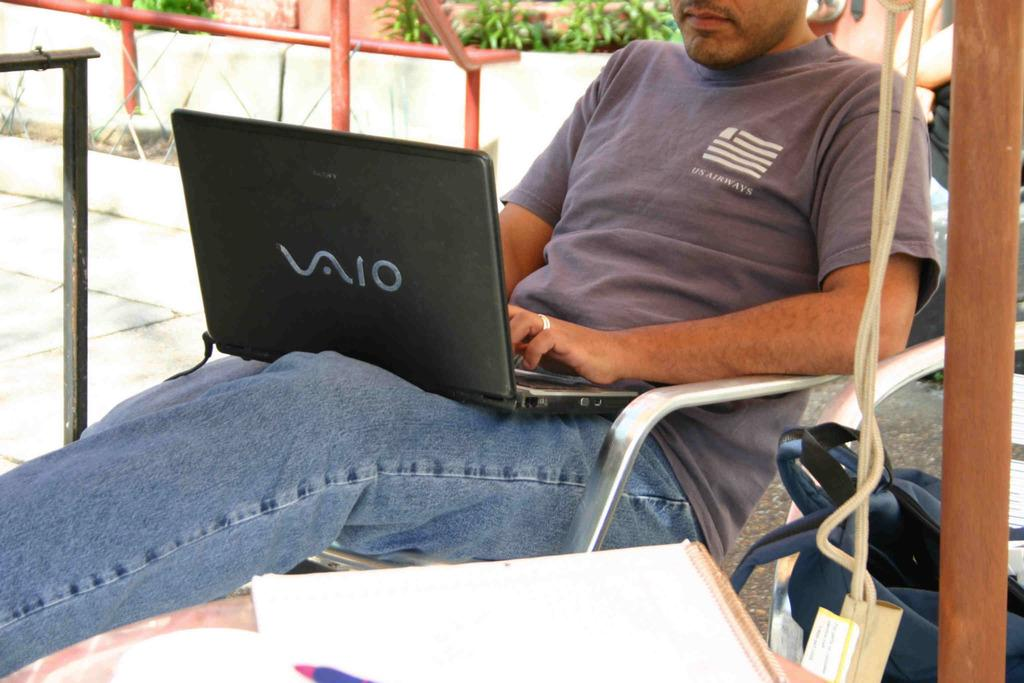What is the man in the image doing? The man is sitting on a chair in the image. What is the man holding or using in the image? The man has a laptop on him. What items related to writing or documentation can be seen in the image? There are papers and a pen in the image. What personal item is visible in the image? There is a bag in the image. What type of objects can be seen in the image that are not related to the man or his belongings? There are rods and plants in the image. What part of the room or setting is visible in the image? The floor is visible in the image. Are there any other objects in the image that have not been mentioned yet? There are some unspecified objects in the image. How does the man in the image wash his throat? There is no indication in the image that the man is washing his throat, and no objects related to throat washing are present. 